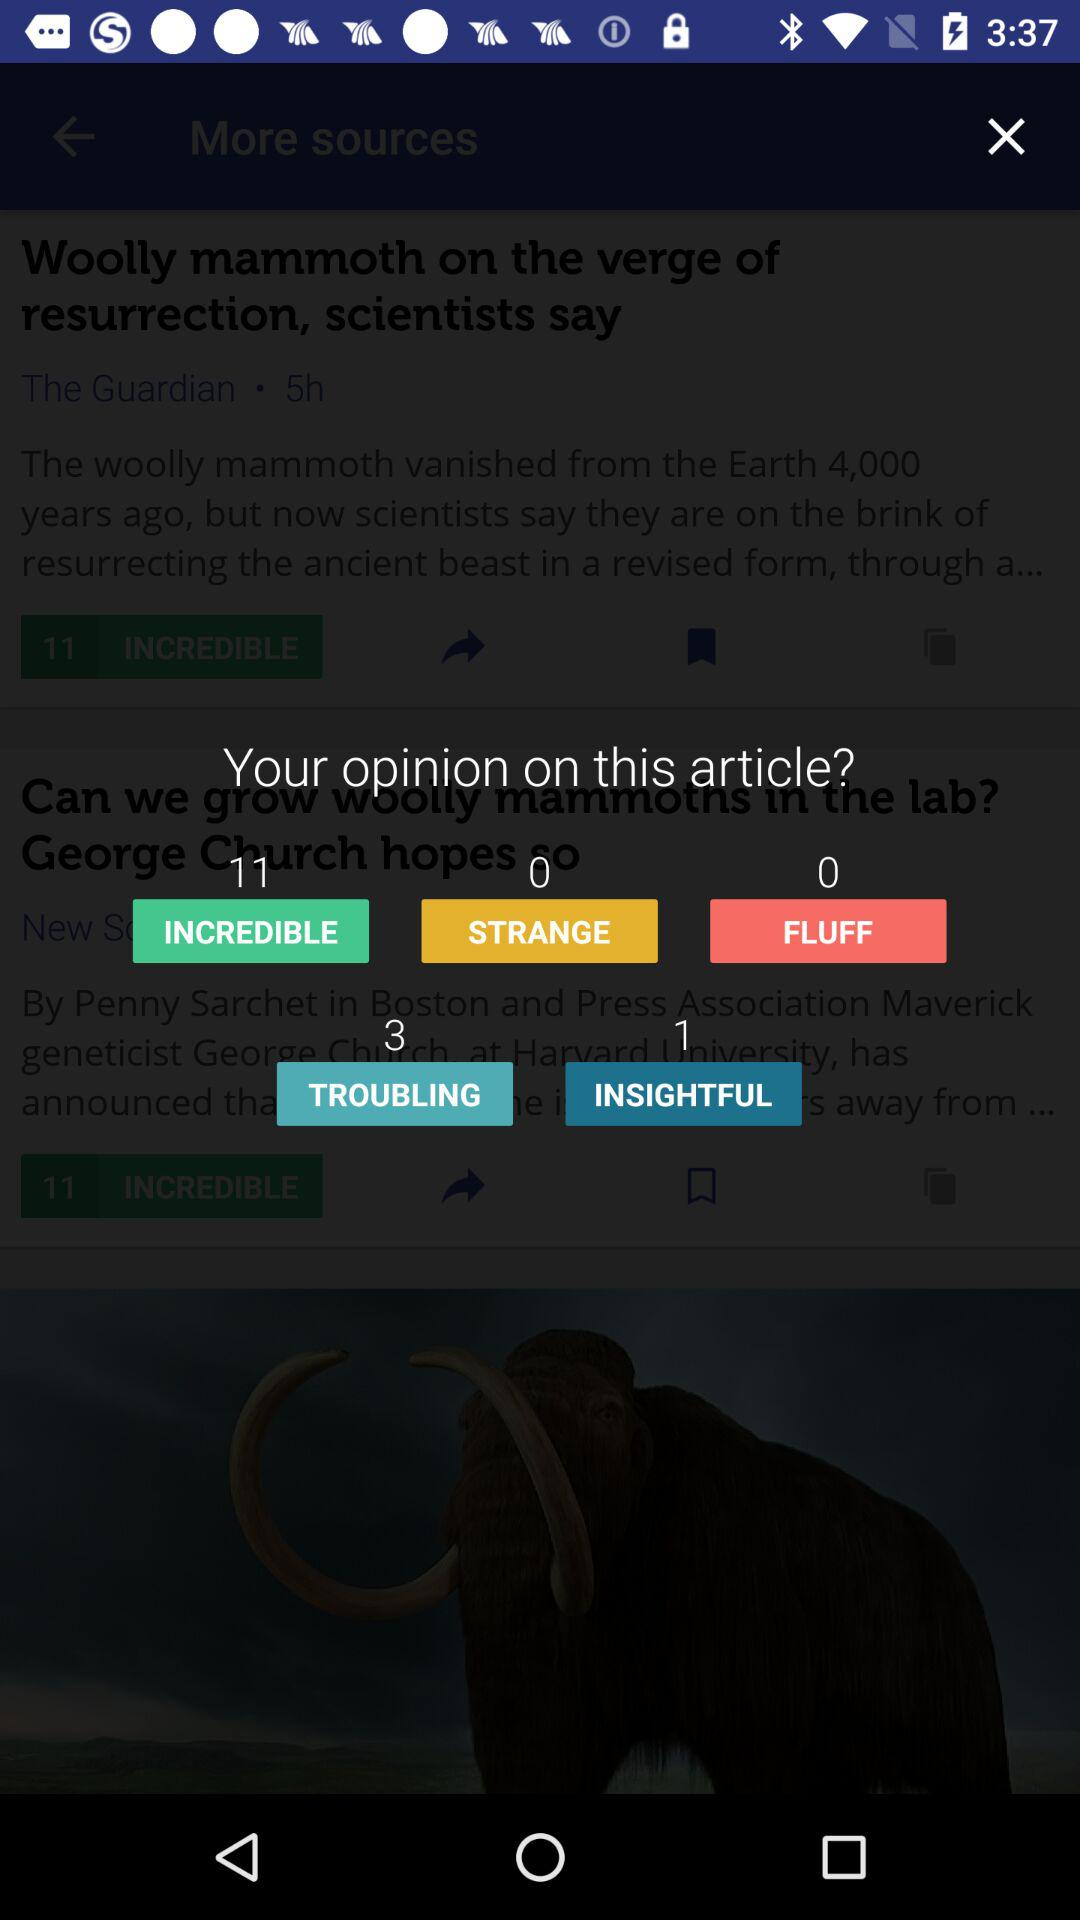How many people think the article is "FLUFF"? The number of people who think the article is "FLUFF" is 0. 